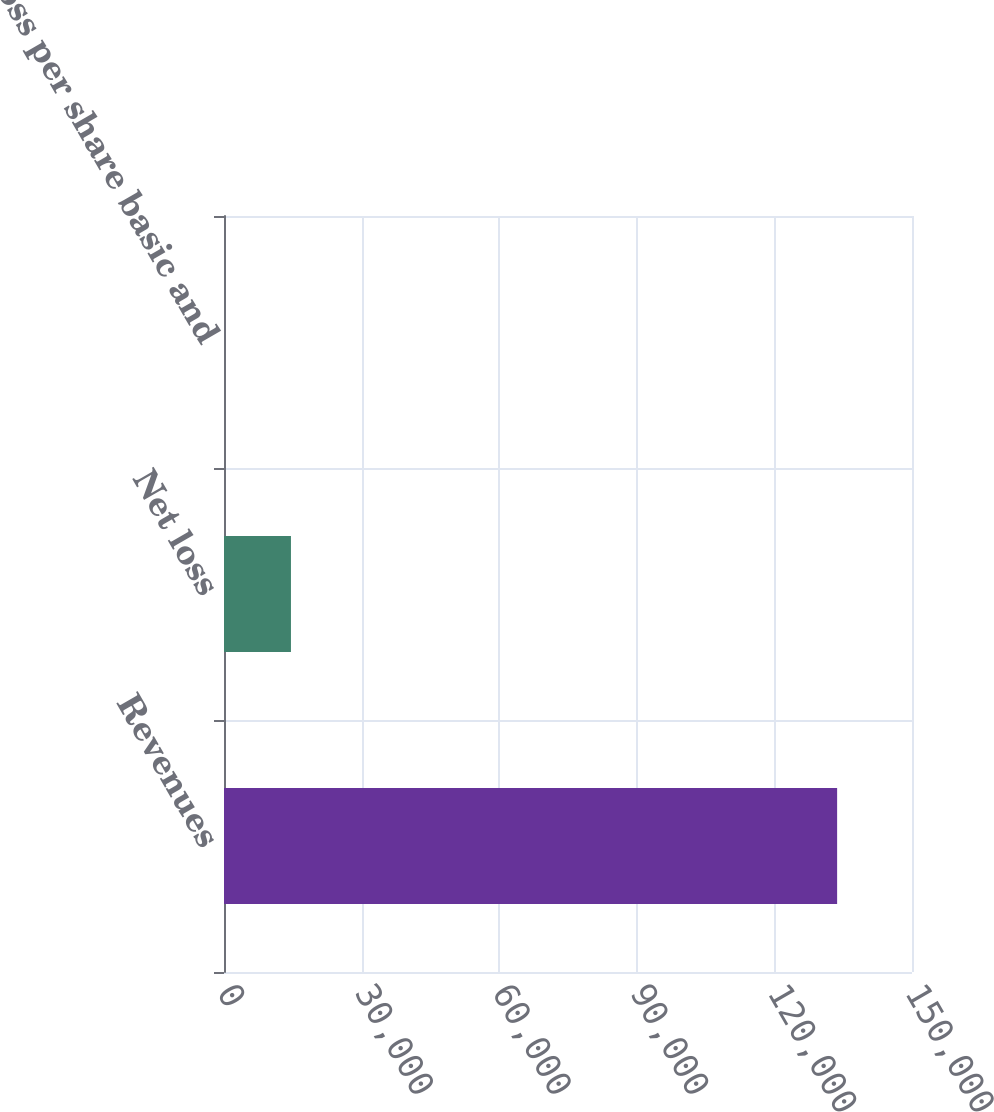<chart> <loc_0><loc_0><loc_500><loc_500><bar_chart><fcel>Revenues<fcel>Net loss<fcel>Net loss per share basic and<nl><fcel>133675<fcel>14597<fcel>0.17<nl></chart> 